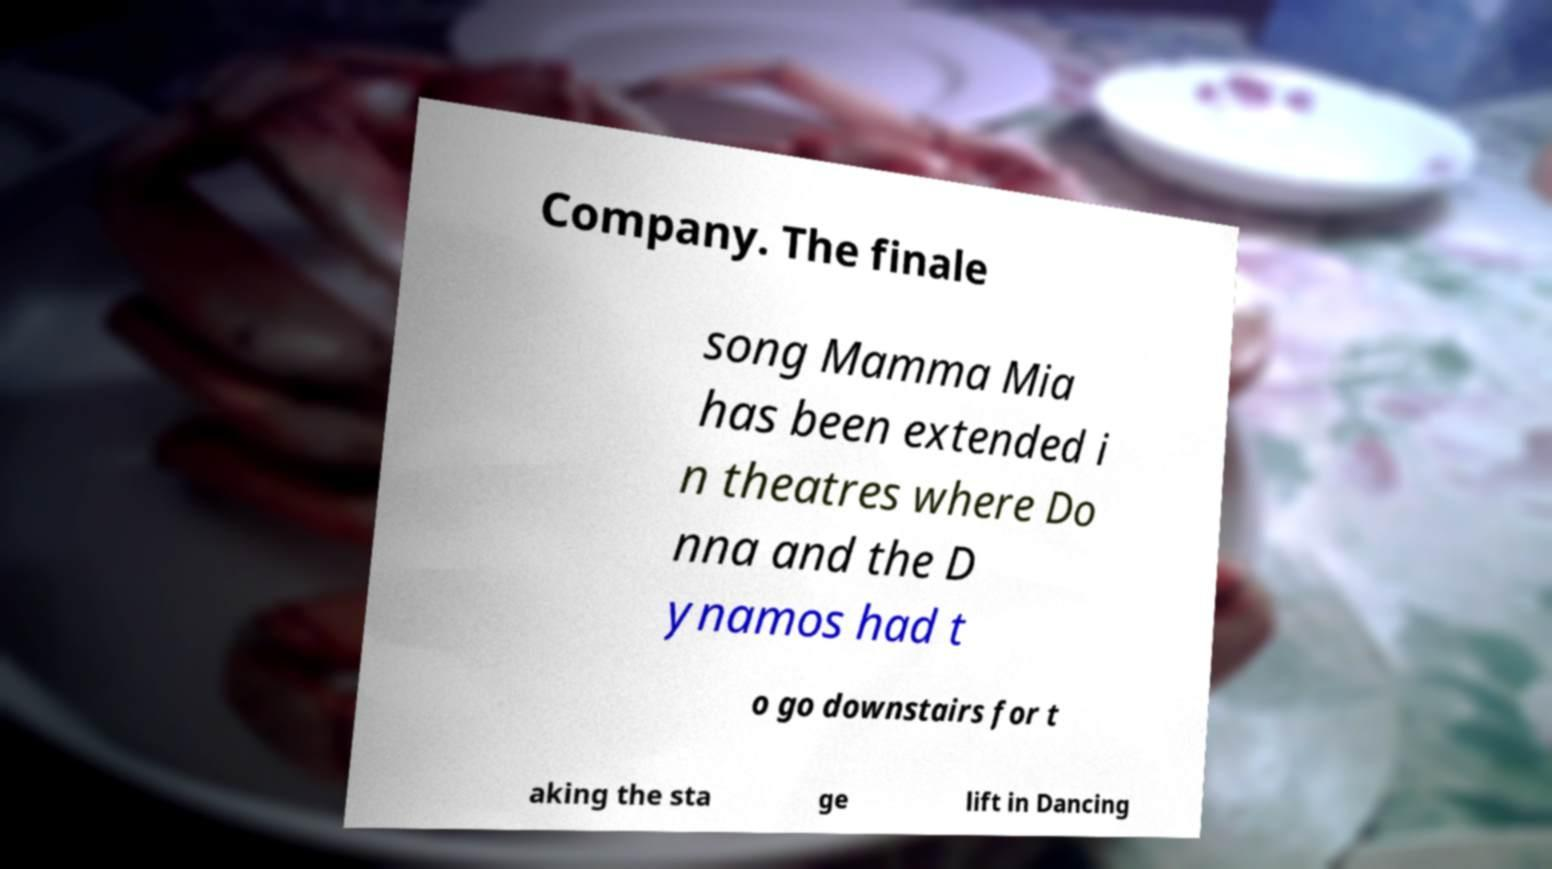Could you extract and type out the text from this image? Company. The finale song Mamma Mia has been extended i n theatres where Do nna and the D ynamos had t o go downstairs for t aking the sta ge lift in Dancing 